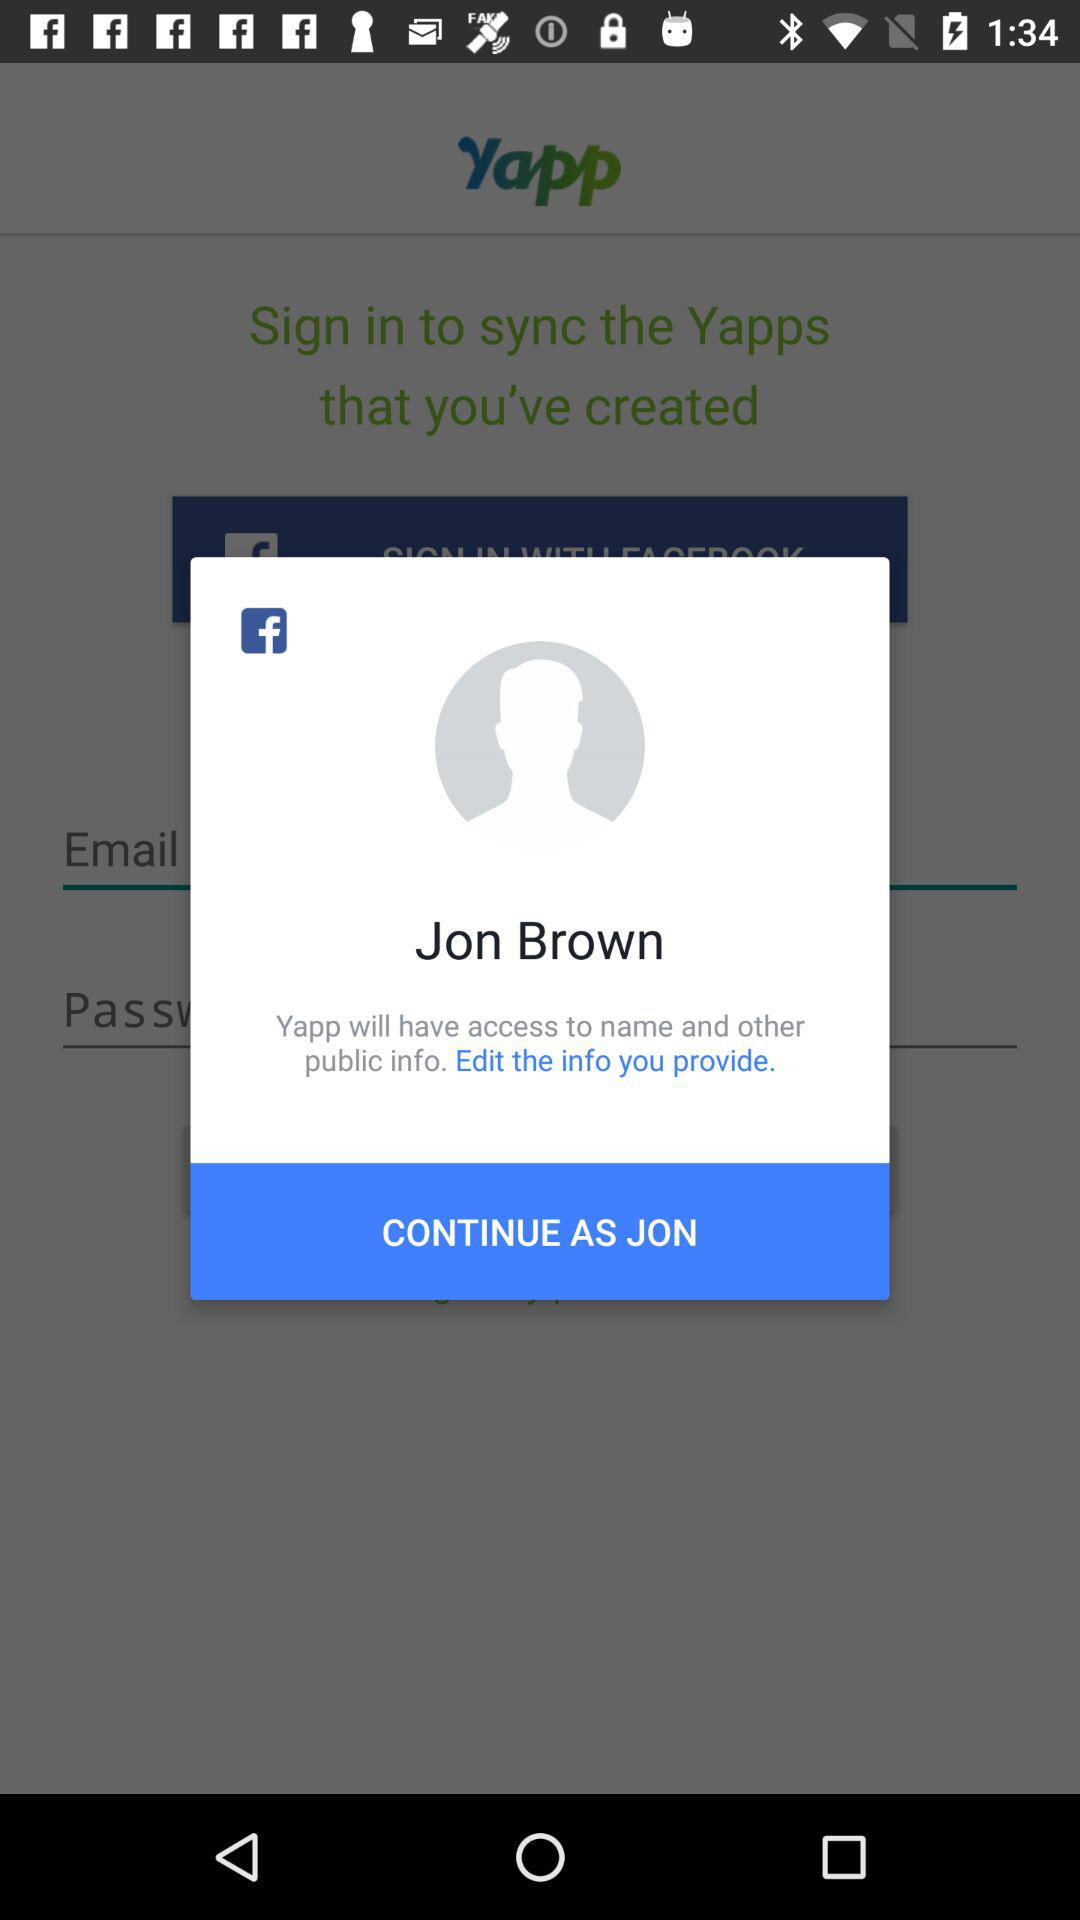What is the name of the user? The name of the user is Jon Brown. 